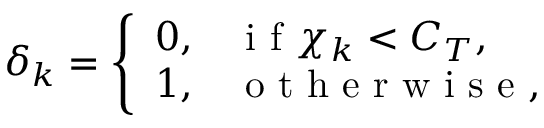Convert formula to latex. <formula><loc_0><loc_0><loc_500><loc_500>\delta _ { k } = \left \{ \begin{array} { l l } { 0 , } & { i f \chi _ { k } < C _ { T } , } \\ { 1 , } & { o t h e r w i s e , } \end{array}</formula> 